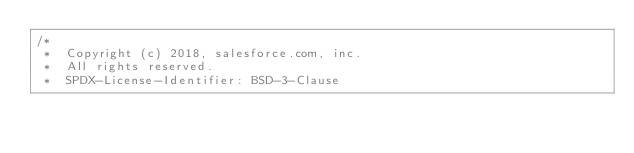Convert code to text. <code><loc_0><loc_0><loc_500><loc_500><_Kotlin_>/*
 *  Copyright (c) 2018, salesforce.com, inc.
 *  All rights reserved.
 *  SPDX-License-Identifier: BSD-3-Clause</code> 